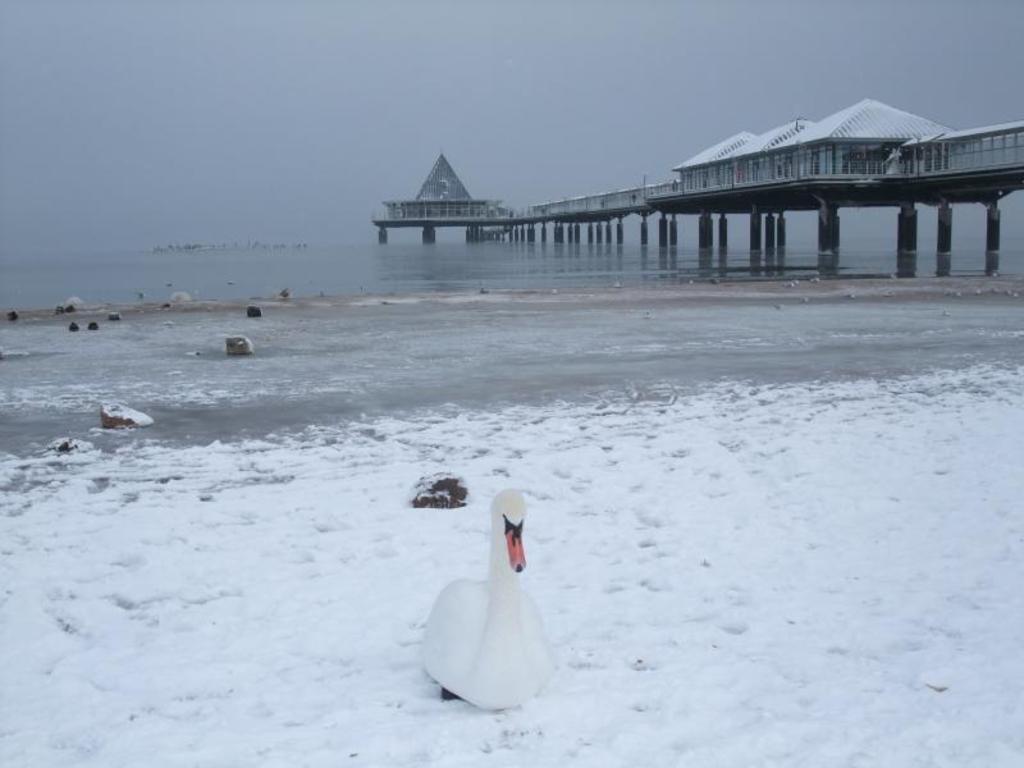In one or two sentences, can you explain what this image depicts? In this picture we can see a bird in the front, at the bottom there is snow, we can see water in the background, on the left side there are some stones, we can see a bridge on the right side, there is the sky at the top of the picture. 